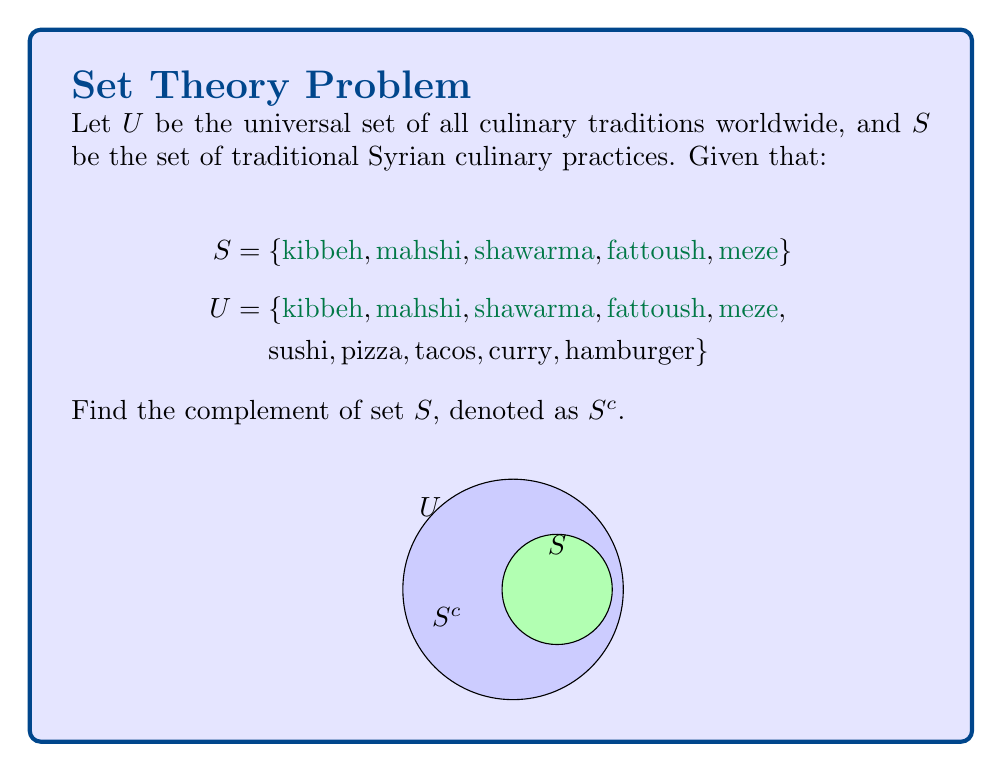Show me your answer to this math problem. To find the complement of set $S$, we need to identify all elements in the universal set $U$ that are not in set $S$. Let's follow these steps:

1) First, recall the definition of set complement:
   $S^c = \{x \in U : x \notin S\}$

2) Now, let's list all elements in $U$ that are not in $S$:
   - sushi
   - pizza
   - tacos
   - curry
   - hamburger

3) These elements form the complement set $S^c$.

4) We can write this set using set notation:
   $S^c = \{\text{sushi}, \text{pizza}, \text{tacos}, \text{curry}, \text{hamburger}\}$

5) To verify, we can check that:
   $S \cup S^c = U$ and $S \cap S^c = \emptyset$

This complement set $S^c$ represents culinary traditions from around the world that are not part of traditional Syrian cuisine, highlighting the unique aspects of Syrian culinary culture in a global context.
Answer: $S^c = \{\text{sushi}, \text{pizza}, \text{tacos}, \text{curry}, \text{hamburger}\}$ 